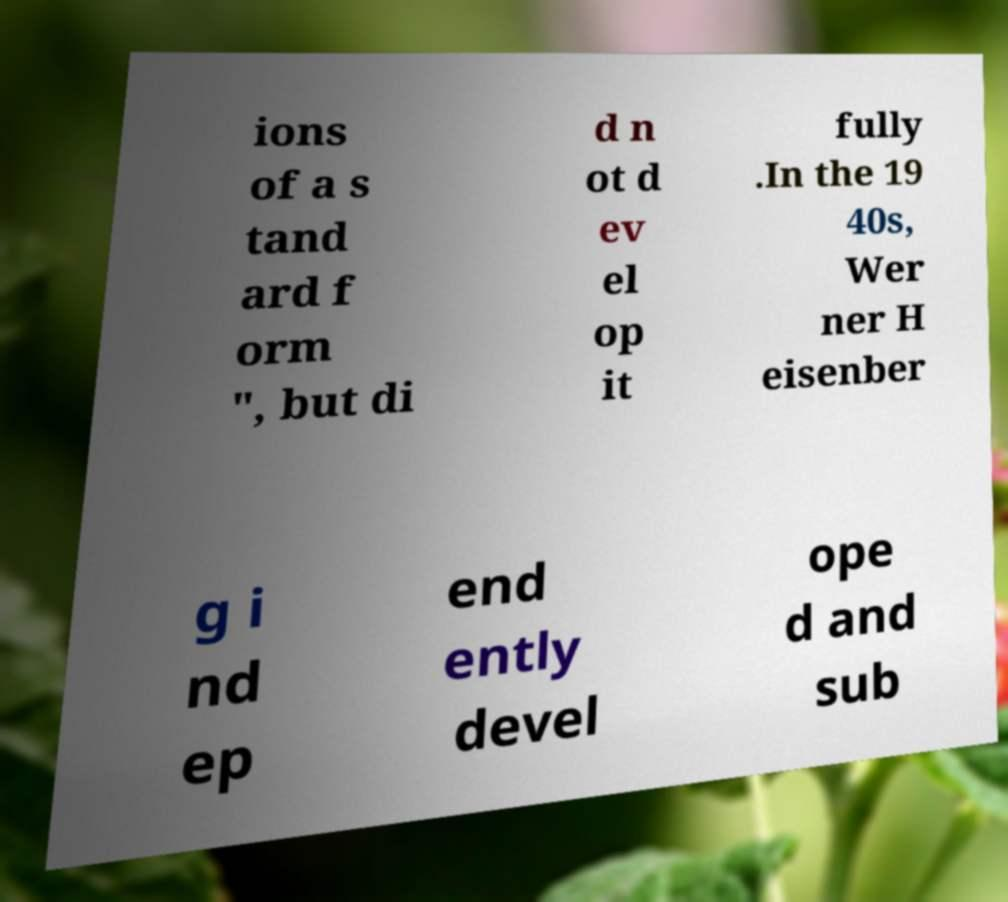What messages or text are displayed in this image? I need them in a readable, typed format. ions of a s tand ard f orm ", but di d n ot d ev el op it fully .In the 19 40s, Wer ner H eisenber g i nd ep end ently devel ope d and sub 